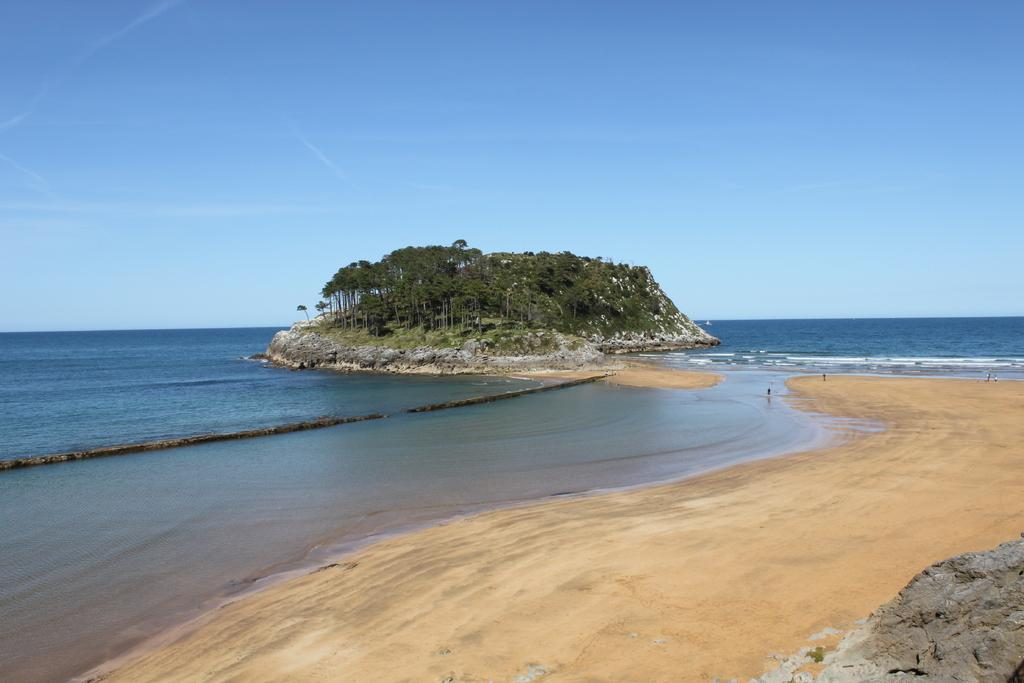What type of natural features can be seen in the image? There are trees, a mountain, and a rock visible in the image. What part of the natural environment is visible in the image? The sky and the ocean are visible in the image. Can you describe the landscape in the image? The image features a mountain, trees, and a rock, with the ocean and sky visible in the background. What is the distribution of the rocks in the image? There is only one rock visible in the image, so it cannot be described as having a distribution. 